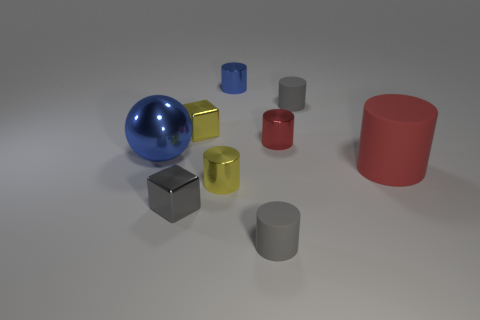What number of other things are there of the same color as the big sphere?
Your response must be concise. 1. There is a big metallic object; is its color the same as the small shiny cylinder behind the small red object?
Your answer should be compact. Yes. There is a yellow metallic block; what number of gray objects are in front of it?
Ensure brevity in your answer.  2. Is the number of big red rubber cylinders behind the small blue metallic cylinder the same as the number of small cubes?
Provide a short and direct response. No. What number of objects are either metallic objects or small gray metal things?
Your answer should be compact. 6. Is there anything else that is the same shape as the red shiny thing?
Give a very brief answer. Yes. What is the shape of the small yellow shiny object to the left of the metallic cylinder that is to the left of the tiny blue object?
Give a very brief answer. Cube. What is the shape of the large blue object that is made of the same material as the tiny red object?
Offer a terse response. Sphere. There is a metallic thing that is right of the gray rubber thing in front of the small gray block; what size is it?
Keep it short and to the point. Small. What is the shape of the big blue metallic object?
Your answer should be very brief. Sphere. 